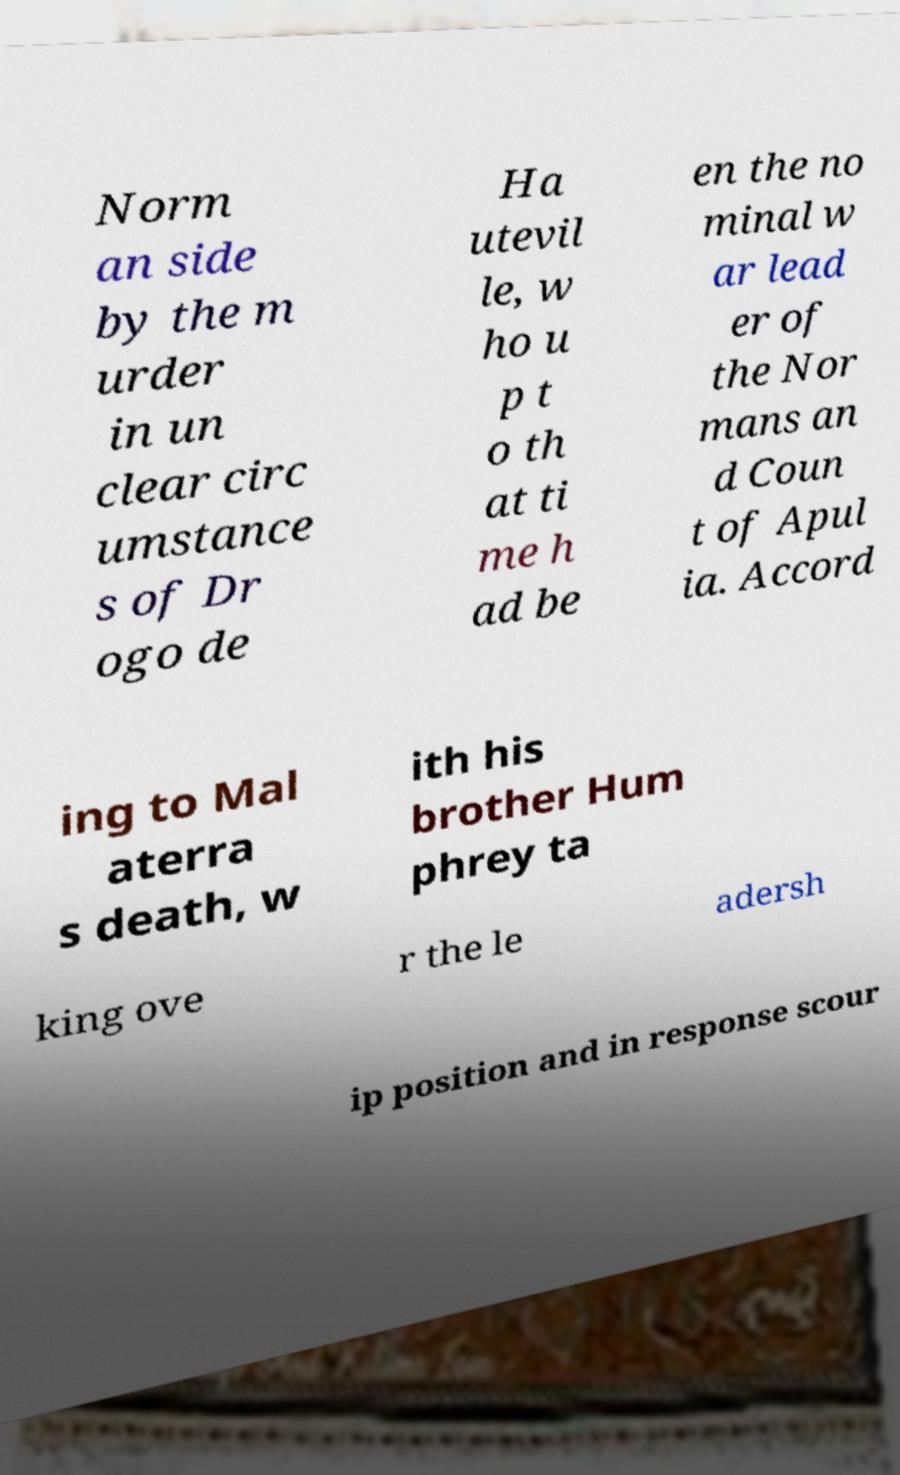Could you extract and type out the text from this image? Norm an side by the m urder in un clear circ umstance s of Dr ogo de Ha utevil le, w ho u p t o th at ti me h ad be en the no minal w ar lead er of the Nor mans an d Coun t of Apul ia. Accord ing to Mal aterra s death, w ith his brother Hum phrey ta king ove r the le adersh ip position and in response scour 